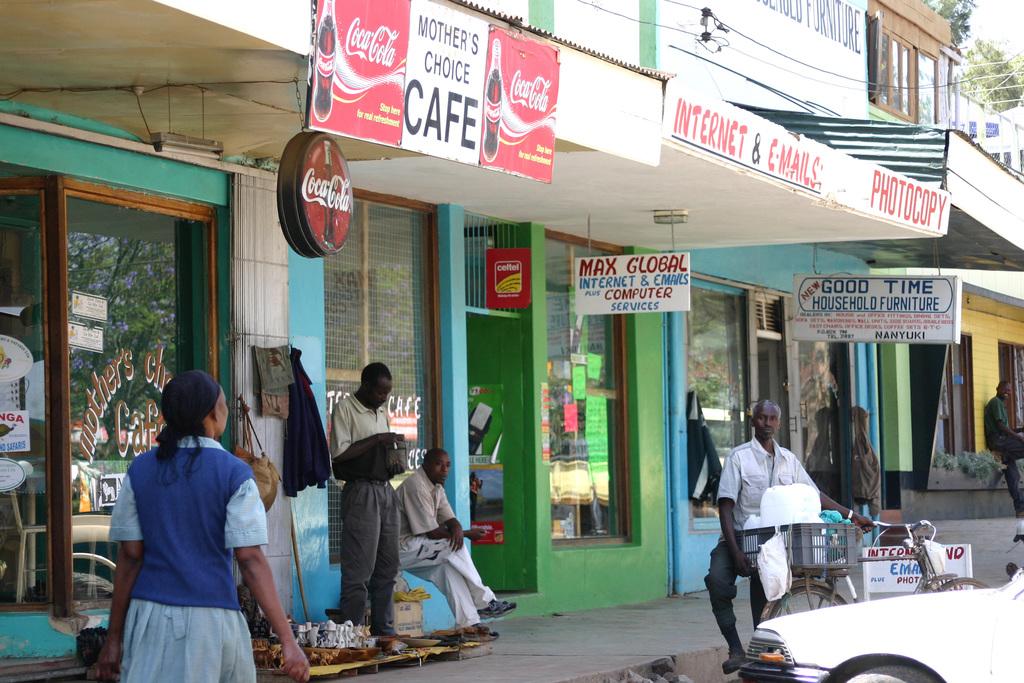What store is this?
Offer a terse response. Cafe. What drink is on the front of the store?
Keep it short and to the point. Coca cola. 